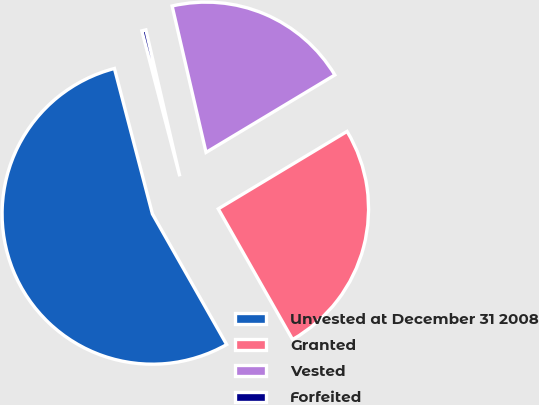Convert chart. <chart><loc_0><loc_0><loc_500><loc_500><pie_chart><fcel>Unvested at December 31 2008<fcel>Granted<fcel>Vested<fcel>Forfeited<nl><fcel>54.17%<fcel>25.39%<fcel>20.01%<fcel>0.44%<nl></chart> 